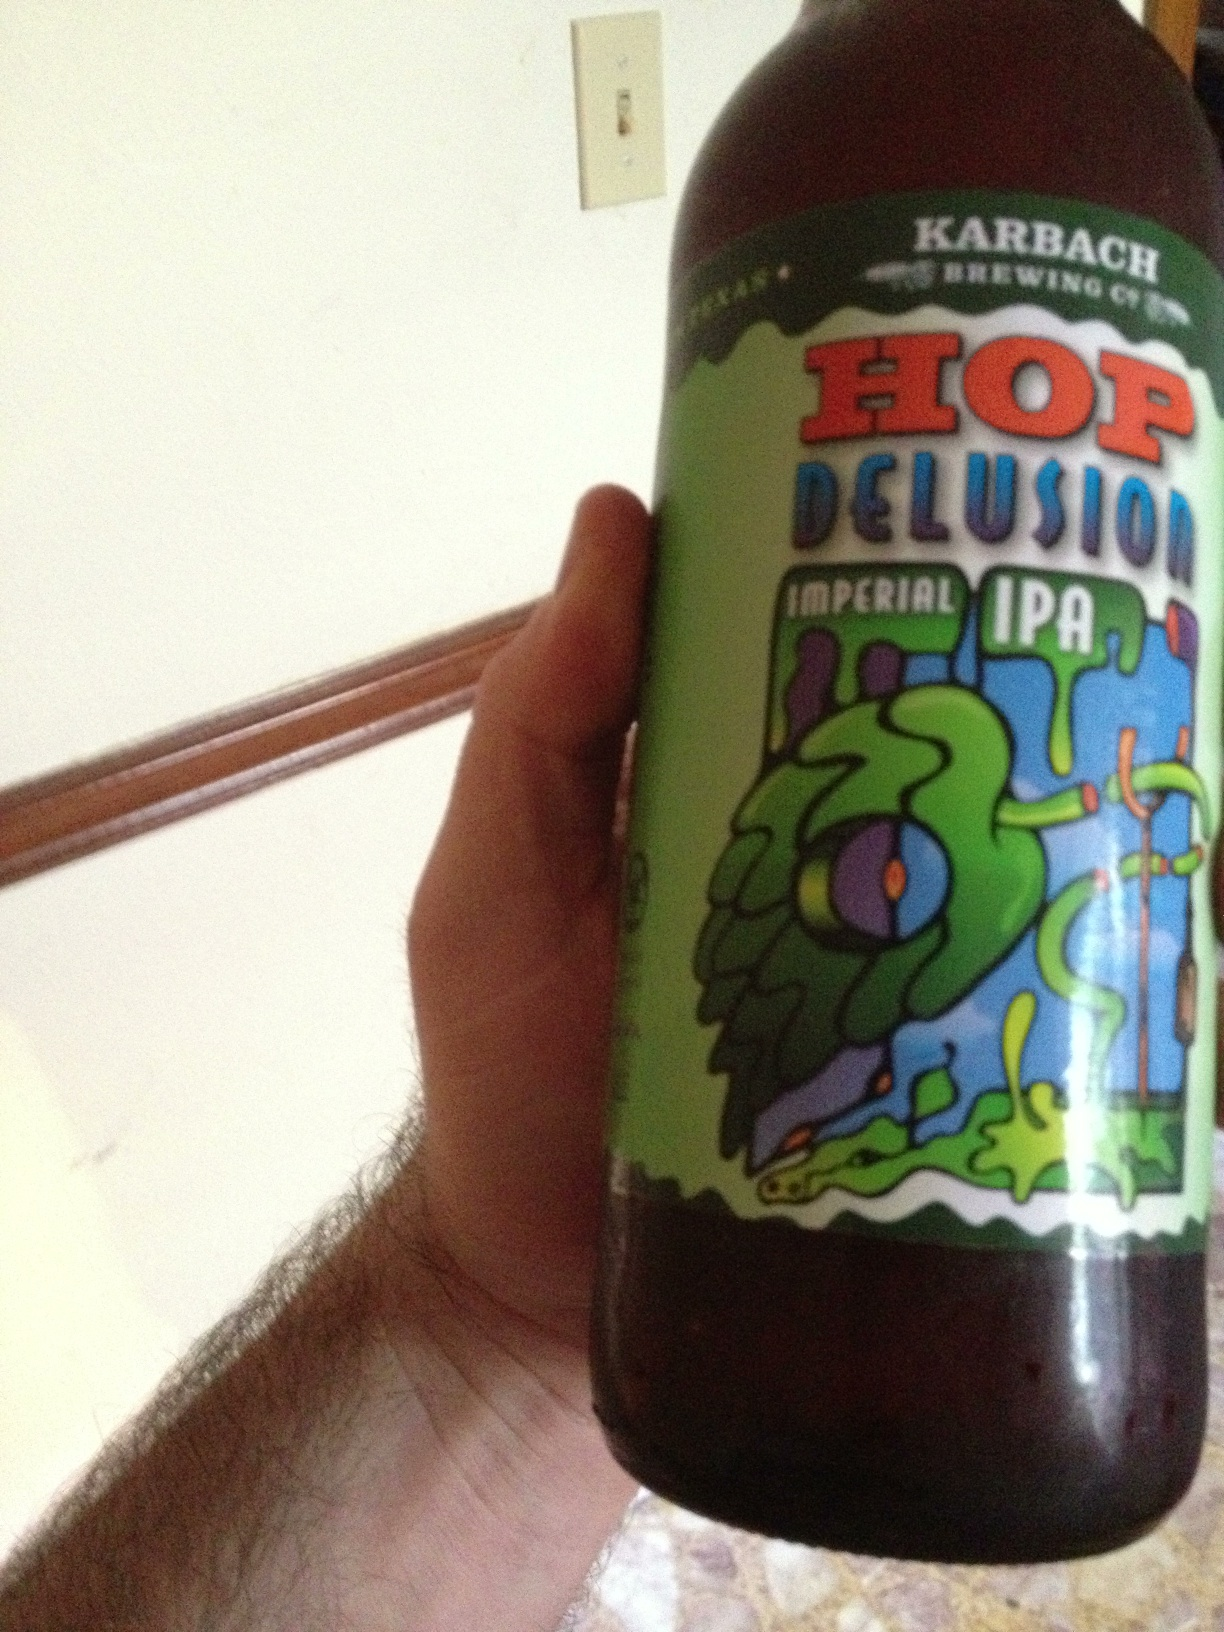How would you describe the taste and aroma of this beer? Hop Delusion Imperial IPA features a robust and complex taste profile with intense hop bitterness balanced by a malty sweetness. The aroma is rich with notes of citrus, pine, and floral undertones, contributing to a refreshing and bold sensory experience. 